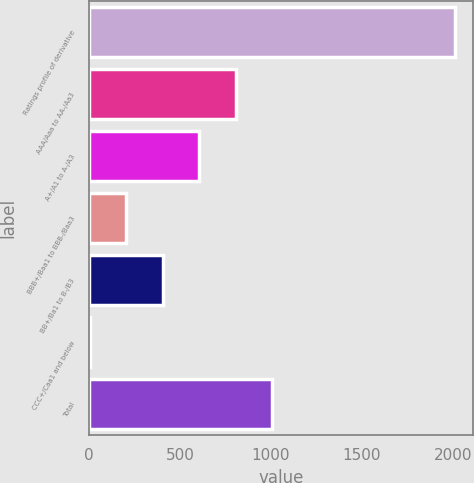Convert chart. <chart><loc_0><loc_0><loc_500><loc_500><bar_chart><fcel>Ratings profile of derivative<fcel>AAA/Aaa to AA-/Aa3<fcel>A+/A1 to A-/A3<fcel>BBB+/Baa1 to BBB-/Baa3<fcel>BB+/Ba1 to B-/B3<fcel>CCC+/Caa1 and below<fcel>Total<nl><fcel>2011<fcel>806.8<fcel>606.1<fcel>204.7<fcel>405.4<fcel>4<fcel>1007.5<nl></chart> 